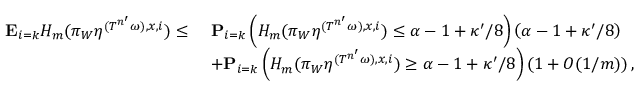Convert formula to latex. <formula><loc_0><loc_0><loc_500><loc_500>\begin{array} { r l } { \mathbf E _ { i = k } H _ { m } ( \pi _ { W } \eta ^ { ( { T ^ { n ^ { \prime } } \omega } ) , x , i } ) \leq \ } & { \mathbf P _ { i = k } \left ( H _ { m } ( \pi _ { W } \eta ^ { ( { T ^ { n ^ { \prime } } \omega } ) , x , i } ) \leq \alpha - 1 + \kappa ^ { \prime } / 8 \right ) \left ( \alpha - 1 + \kappa ^ { \prime } / 8 \right ) } \\ & { + \mathbf P _ { i = k } \left ( H _ { m } ( \pi _ { W } \eta ^ { ( { T ^ { n ^ { \prime } } \omega } ) , x , i } ) \geq \alpha - 1 + \kappa ^ { \prime } / 8 \right ) \left ( 1 + O ( 1 / m ) \right ) , } \end{array}</formula> 